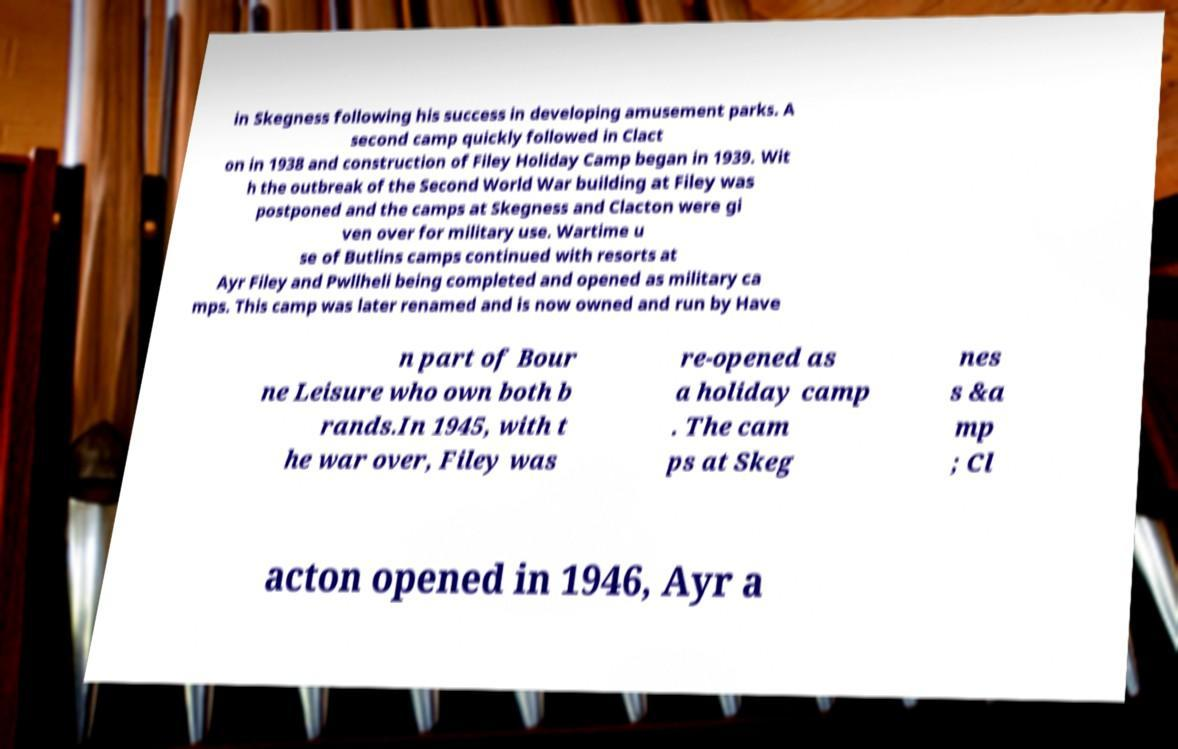For documentation purposes, I need the text within this image transcribed. Could you provide that? in Skegness following his success in developing amusement parks. A second camp quickly followed in Clact on in 1938 and construction of Filey Holiday Camp began in 1939. Wit h the outbreak of the Second World War building at Filey was postponed and the camps at Skegness and Clacton were gi ven over for military use. Wartime u se of Butlins camps continued with resorts at Ayr Filey and Pwllheli being completed and opened as military ca mps. This camp was later renamed and is now owned and run by Have n part of Bour ne Leisure who own both b rands.In 1945, with t he war over, Filey was re-opened as a holiday camp . The cam ps at Skeg nes s &a mp ; Cl acton opened in 1946, Ayr a 